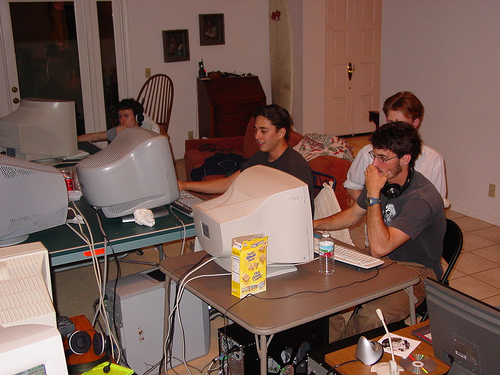Can you describe the setting and possible era this image depicts? The image depicts a room with older model CRT monitors and personal computers that suggest it might be from the late 1990s or early 2000s. Given the informal setup with snacks, scattered papers, and a relaxed atmosphere, it could be a snapshot from a LAN party or a startup's early days. 